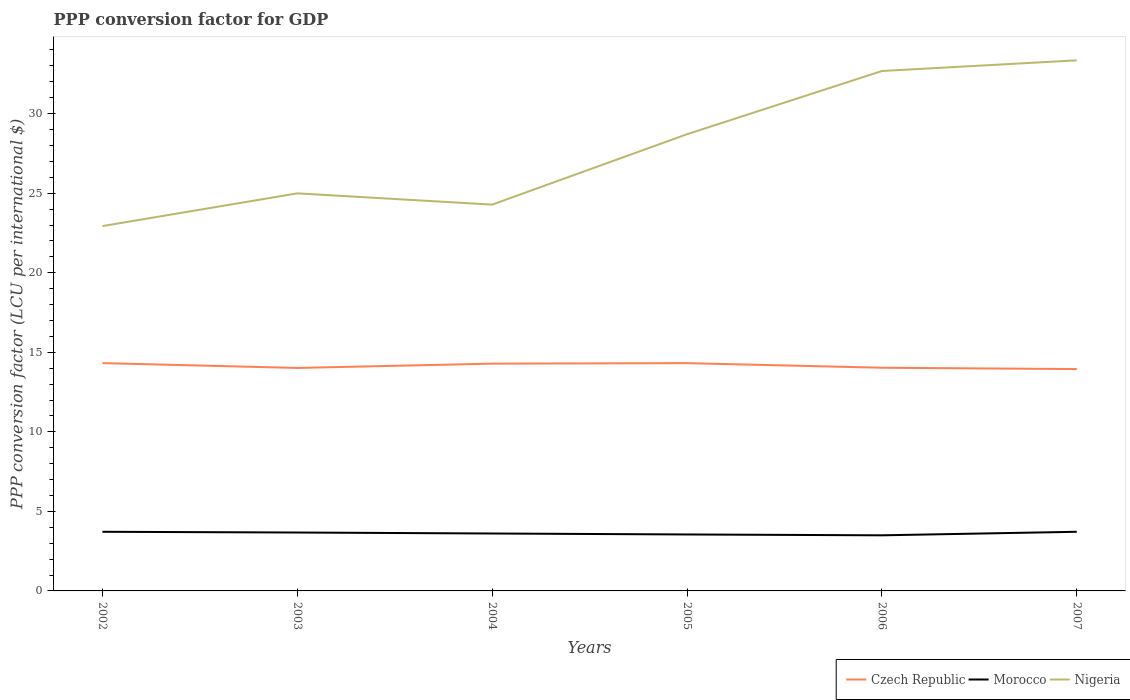How many different coloured lines are there?
Keep it short and to the point. 3. Does the line corresponding to Nigeria intersect with the line corresponding to Czech Republic?
Ensure brevity in your answer.  No. Is the number of lines equal to the number of legend labels?
Ensure brevity in your answer.  Yes. Across all years, what is the maximum PPP conversion factor for GDP in Morocco?
Your response must be concise. 3.49. What is the total PPP conversion factor for GDP in Nigeria in the graph?
Provide a succinct answer. -10.42. What is the difference between the highest and the second highest PPP conversion factor for GDP in Morocco?
Offer a terse response. 0.22. What is the difference between the highest and the lowest PPP conversion factor for GDP in Czech Republic?
Offer a terse response. 3. Is the PPP conversion factor for GDP in Czech Republic strictly greater than the PPP conversion factor for GDP in Nigeria over the years?
Your answer should be very brief. Yes. How many lines are there?
Keep it short and to the point. 3. How many years are there in the graph?
Offer a very short reply. 6. Are the values on the major ticks of Y-axis written in scientific E-notation?
Offer a terse response. No. Does the graph contain grids?
Offer a terse response. No. Where does the legend appear in the graph?
Offer a terse response. Bottom right. How are the legend labels stacked?
Give a very brief answer. Horizontal. What is the title of the graph?
Make the answer very short. PPP conversion factor for GDP. Does "Luxembourg" appear as one of the legend labels in the graph?
Ensure brevity in your answer.  No. What is the label or title of the Y-axis?
Offer a terse response. PPP conversion factor (LCU per international $). What is the PPP conversion factor (LCU per international $) of Czech Republic in 2002?
Offer a very short reply. 14.32. What is the PPP conversion factor (LCU per international $) of Morocco in 2002?
Keep it short and to the point. 3.72. What is the PPP conversion factor (LCU per international $) of Nigeria in 2002?
Offer a terse response. 22.93. What is the PPP conversion factor (LCU per international $) in Czech Republic in 2003?
Provide a short and direct response. 14.01. What is the PPP conversion factor (LCU per international $) of Morocco in 2003?
Provide a succinct answer. 3.67. What is the PPP conversion factor (LCU per international $) of Nigeria in 2003?
Ensure brevity in your answer.  24.99. What is the PPP conversion factor (LCU per international $) in Czech Republic in 2004?
Provide a short and direct response. 14.29. What is the PPP conversion factor (LCU per international $) in Morocco in 2004?
Provide a succinct answer. 3.61. What is the PPP conversion factor (LCU per international $) in Nigeria in 2004?
Keep it short and to the point. 24.28. What is the PPP conversion factor (LCU per international $) in Czech Republic in 2005?
Ensure brevity in your answer.  14.32. What is the PPP conversion factor (LCU per international $) in Morocco in 2005?
Your response must be concise. 3.55. What is the PPP conversion factor (LCU per international $) in Nigeria in 2005?
Provide a succinct answer. 28.71. What is the PPP conversion factor (LCU per international $) in Czech Republic in 2006?
Offer a terse response. 14.03. What is the PPP conversion factor (LCU per international $) of Morocco in 2006?
Give a very brief answer. 3.49. What is the PPP conversion factor (LCU per international $) of Nigeria in 2006?
Make the answer very short. 32.68. What is the PPP conversion factor (LCU per international $) in Czech Republic in 2007?
Your answer should be very brief. 13.94. What is the PPP conversion factor (LCU per international $) of Morocco in 2007?
Your response must be concise. 3.72. What is the PPP conversion factor (LCU per international $) in Nigeria in 2007?
Your answer should be compact. 33.35. Across all years, what is the maximum PPP conversion factor (LCU per international $) of Czech Republic?
Offer a terse response. 14.32. Across all years, what is the maximum PPP conversion factor (LCU per international $) in Morocco?
Provide a succinct answer. 3.72. Across all years, what is the maximum PPP conversion factor (LCU per international $) of Nigeria?
Your answer should be very brief. 33.35. Across all years, what is the minimum PPP conversion factor (LCU per international $) of Czech Republic?
Keep it short and to the point. 13.94. Across all years, what is the minimum PPP conversion factor (LCU per international $) of Morocco?
Ensure brevity in your answer.  3.49. Across all years, what is the minimum PPP conversion factor (LCU per international $) in Nigeria?
Offer a very short reply. 22.93. What is the total PPP conversion factor (LCU per international $) in Czech Republic in the graph?
Give a very brief answer. 84.91. What is the total PPP conversion factor (LCU per international $) of Morocco in the graph?
Your answer should be very brief. 21.76. What is the total PPP conversion factor (LCU per international $) in Nigeria in the graph?
Your answer should be very brief. 166.94. What is the difference between the PPP conversion factor (LCU per international $) in Czech Republic in 2002 and that in 2003?
Keep it short and to the point. 0.3. What is the difference between the PPP conversion factor (LCU per international $) in Morocco in 2002 and that in 2003?
Your answer should be compact. 0.05. What is the difference between the PPP conversion factor (LCU per international $) in Nigeria in 2002 and that in 2003?
Offer a terse response. -2.06. What is the difference between the PPP conversion factor (LCU per international $) in Czech Republic in 2002 and that in 2004?
Offer a terse response. 0.03. What is the difference between the PPP conversion factor (LCU per international $) in Morocco in 2002 and that in 2004?
Keep it short and to the point. 0.11. What is the difference between the PPP conversion factor (LCU per international $) in Nigeria in 2002 and that in 2004?
Make the answer very short. -1.35. What is the difference between the PPP conversion factor (LCU per international $) in Czech Republic in 2002 and that in 2005?
Offer a very short reply. 0. What is the difference between the PPP conversion factor (LCU per international $) in Morocco in 2002 and that in 2005?
Ensure brevity in your answer.  0.17. What is the difference between the PPP conversion factor (LCU per international $) of Nigeria in 2002 and that in 2005?
Your answer should be compact. -5.77. What is the difference between the PPP conversion factor (LCU per international $) of Czech Republic in 2002 and that in 2006?
Your answer should be very brief. 0.29. What is the difference between the PPP conversion factor (LCU per international $) in Morocco in 2002 and that in 2006?
Your answer should be compact. 0.22. What is the difference between the PPP conversion factor (LCU per international $) of Nigeria in 2002 and that in 2006?
Offer a terse response. -9.75. What is the difference between the PPP conversion factor (LCU per international $) in Czech Republic in 2002 and that in 2007?
Provide a short and direct response. 0.38. What is the difference between the PPP conversion factor (LCU per international $) of Morocco in 2002 and that in 2007?
Your response must be concise. -0. What is the difference between the PPP conversion factor (LCU per international $) of Nigeria in 2002 and that in 2007?
Your answer should be very brief. -10.42. What is the difference between the PPP conversion factor (LCU per international $) in Czech Republic in 2003 and that in 2004?
Give a very brief answer. -0.27. What is the difference between the PPP conversion factor (LCU per international $) of Morocco in 2003 and that in 2004?
Offer a very short reply. 0.06. What is the difference between the PPP conversion factor (LCU per international $) of Nigeria in 2003 and that in 2004?
Your response must be concise. 0.71. What is the difference between the PPP conversion factor (LCU per international $) of Czech Republic in 2003 and that in 2005?
Offer a terse response. -0.3. What is the difference between the PPP conversion factor (LCU per international $) of Morocco in 2003 and that in 2005?
Make the answer very short. 0.12. What is the difference between the PPP conversion factor (LCU per international $) of Nigeria in 2003 and that in 2005?
Provide a succinct answer. -3.72. What is the difference between the PPP conversion factor (LCU per international $) in Czech Republic in 2003 and that in 2006?
Provide a short and direct response. -0.01. What is the difference between the PPP conversion factor (LCU per international $) of Morocco in 2003 and that in 2006?
Make the answer very short. 0.18. What is the difference between the PPP conversion factor (LCU per international $) of Nigeria in 2003 and that in 2006?
Provide a succinct answer. -7.69. What is the difference between the PPP conversion factor (LCU per international $) in Czech Republic in 2003 and that in 2007?
Your response must be concise. 0.07. What is the difference between the PPP conversion factor (LCU per international $) of Morocco in 2003 and that in 2007?
Your response must be concise. -0.05. What is the difference between the PPP conversion factor (LCU per international $) of Nigeria in 2003 and that in 2007?
Give a very brief answer. -8.36. What is the difference between the PPP conversion factor (LCU per international $) of Czech Republic in 2004 and that in 2005?
Offer a terse response. -0.03. What is the difference between the PPP conversion factor (LCU per international $) of Morocco in 2004 and that in 2005?
Give a very brief answer. 0.06. What is the difference between the PPP conversion factor (LCU per international $) in Nigeria in 2004 and that in 2005?
Ensure brevity in your answer.  -4.42. What is the difference between the PPP conversion factor (LCU per international $) of Czech Republic in 2004 and that in 2006?
Provide a short and direct response. 0.26. What is the difference between the PPP conversion factor (LCU per international $) in Morocco in 2004 and that in 2006?
Your response must be concise. 0.11. What is the difference between the PPP conversion factor (LCU per international $) in Nigeria in 2004 and that in 2006?
Your answer should be very brief. -8.4. What is the difference between the PPP conversion factor (LCU per international $) of Czech Republic in 2004 and that in 2007?
Your answer should be very brief. 0.34. What is the difference between the PPP conversion factor (LCU per international $) of Morocco in 2004 and that in 2007?
Your answer should be very brief. -0.11. What is the difference between the PPP conversion factor (LCU per international $) in Nigeria in 2004 and that in 2007?
Provide a short and direct response. -9.07. What is the difference between the PPP conversion factor (LCU per international $) in Czech Republic in 2005 and that in 2006?
Ensure brevity in your answer.  0.29. What is the difference between the PPP conversion factor (LCU per international $) in Morocco in 2005 and that in 2006?
Your answer should be very brief. 0.05. What is the difference between the PPP conversion factor (LCU per international $) of Nigeria in 2005 and that in 2006?
Offer a terse response. -3.97. What is the difference between the PPP conversion factor (LCU per international $) of Czech Republic in 2005 and that in 2007?
Offer a very short reply. 0.37. What is the difference between the PPP conversion factor (LCU per international $) of Morocco in 2005 and that in 2007?
Make the answer very short. -0.17. What is the difference between the PPP conversion factor (LCU per international $) of Nigeria in 2005 and that in 2007?
Provide a succinct answer. -4.64. What is the difference between the PPP conversion factor (LCU per international $) of Czech Republic in 2006 and that in 2007?
Your response must be concise. 0.09. What is the difference between the PPP conversion factor (LCU per international $) in Morocco in 2006 and that in 2007?
Provide a succinct answer. -0.22. What is the difference between the PPP conversion factor (LCU per international $) in Nigeria in 2006 and that in 2007?
Provide a succinct answer. -0.67. What is the difference between the PPP conversion factor (LCU per international $) in Czech Republic in 2002 and the PPP conversion factor (LCU per international $) in Morocco in 2003?
Your answer should be compact. 10.65. What is the difference between the PPP conversion factor (LCU per international $) of Czech Republic in 2002 and the PPP conversion factor (LCU per international $) of Nigeria in 2003?
Provide a short and direct response. -10.67. What is the difference between the PPP conversion factor (LCU per international $) in Morocco in 2002 and the PPP conversion factor (LCU per international $) in Nigeria in 2003?
Provide a succinct answer. -21.27. What is the difference between the PPP conversion factor (LCU per international $) of Czech Republic in 2002 and the PPP conversion factor (LCU per international $) of Morocco in 2004?
Offer a very short reply. 10.71. What is the difference between the PPP conversion factor (LCU per international $) in Czech Republic in 2002 and the PPP conversion factor (LCU per international $) in Nigeria in 2004?
Make the answer very short. -9.96. What is the difference between the PPP conversion factor (LCU per international $) in Morocco in 2002 and the PPP conversion factor (LCU per international $) in Nigeria in 2004?
Give a very brief answer. -20.57. What is the difference between the PPP conversion factor (LCU per international $) of Czech Republic in 2002 and the PPP conversion factor (LCU per international $) of Morocco in 2005?
Your answer should be very brief. 10.77. What is the difference between the PPP conversion factor (LCU per international $) in Czech Republic in 2002 and the PPP conversion factor (LCU per international $) in Nigeria in 2005?
Provide a short and direct response. -14.39. What is the difference between the PPP conversion factor (LCU per international $) of Morocco in 2002 and the PPP conversion factor (LCU per international $) of Nigeria in 2005?
Provide a short and direct response. -24.99. What is the difference between the PPP conversion factor (LCU per international $) of Czech Republic in 2002 and the PPP conversion factor (LCU per international $) of Morocco in 2006?
Provide a short and direct response. 10.82. What is the difference between the PPP conversion factor (LCU per international $) of Czech Republic in 2002 and the PPP conversion factor (LCU per international $) of Nigeria in 2006?
Your answer should be very brief. -18.36. What is the difference between the PPP conversion factor (LCU per international $) in Morocco in 2002 and the PPP conversion factor (LCU per international $) in Nigeria in 2006?
Offer a terse response. -28.96. What is the difference between the PPP conversion factor (LCU per international $) of Czech Republic in 2002 and the PPP conversion factor (LCU per international $) of Morocco in 2007?
Your response must be concise. 10.6. What is the difference between the PPP conversion factor (LCU per international $) in Czech Republic in 2002 and the PPP conversion factor (LCU per international $) in Nigeria in 2007?
Ensure brevity in your answer.  -19.03. What is the difference between the PPP conversion factor (LCU per international $) of Morocco in 2002 and the PPP conversion factor (LCU per international $) of Nigeria in 2007?
Provide a short and direct response. -29.63. What is the difference between the PPP conversion factor (LCU per international $) in Czech Republic in 2003 and the PPP conversion factor (LCU per international $) in Morocco in 2004?
Keep it short and to the point. 10.41. What is the difference between the PPP conversion factor (LCU per international $) in Czech Republic in 2003 and the PPP conversion factor (LCU per international $) in Nigeria in 2004?
Your response must be concise. -10.27. What is the difference between the PPP conversion factor (LCU per international $) in Morocco in 2003 and the PPP conversion factor (LCU per international $) in Nigeria in 2004?
Provide a short and direct response. -20.61. What is the difference between the PPP conversion factor (LCU per international $) in Czech Republic in 2003 and the PPP conversion factor (LCU per international $) in Morocco in 2005?
Provide a succinct answer. 10.47. What is the difference between the PPP conversion factor (LCU per international $) of Czech Republic in 2003 and the PPP conversion factor (LCU per international $) of Nigeria in 2005?
Make the answer very short. -14.69. What is the difference between the PPP conversion factor (LCU per international $) of Morocco in 2003 and the PPP conversion factor (LCU per international $) of Nigeria in 2005?
Provide a succinct answer. -25.04. What is the difference between the PPP conversion factor (LCU per international $) of Czech Republic in 2003 and the PPP conversion factor (LCU per international $) of Morocco in 2006?
Provide a short and direct response. 10.52. What is the difference between the PPP conversion factor (LCU per international $) of Czech Republic in 2003 and the PPP conversion factor (LCU per international $) of Nigeria in 2006?
Ensure brevity in your answer.  -18.67. What is the difference between the PPP conversion factor (LCU per international $) of Morocco in 2003 and the PPP conversion factor (LCU per international $) of Nigeria in 2006?
Offer a very short reply. -29.01. What is the difference between the PPP conversion factor (LCU per international $) in Czech Republic in 2003 and the PPP conversion factor (LCU per international $) in Morocco in 2007?
Ensure brevity in your answer.  10.3. What is the difference between the PPP conversion factor (LCU per international $) of Czech Republic in 2003 and the PPP conversion factor (LCU per international $) of Nigeria in 2007?
Make the answer very short. -19.34. What is the difference between the PPP conversion factor (LCU per international $) of Morocco in 2003 and the PPP conversion factor (LCU per international $) of Nigeria in 2007?
Provide a succinct answer. -29.68. What is the difference between the PPP conversion factor (LCU per international $) of Czech Republic in 2004 and the PPP conversion factor (LCU per international $) of Morocco in 2005?
Keep it short and to the point. 10.74. What is the difference between the PPP conversion factor (LCU per international $) in Czech Republic in 2004 and the PPP conversion factor (LCU per international $) in Nigeria in 2005?
Your response must be concise. -14.42. What is the difference between the PPP conversion factor (LCU per international $) in Morocco in 2004 and the PPP conversion factor (LCU per international $) in Nigeria in 2005?
Provide a short and direct response. -25.1. What is the difference between the PPP conversion factor (LCU per international $) of Czech Republic in 2004 and the PPP conversion factor (LCU per international $) of Morocco in 2006?
Offer a very short reply. 10.79. What is the difference between the PPP conversion factor (LCU per international $) in Czech Republic in 2004 and the PPP conversion factor (LCU per international $) in Nigeria in 2006?
Give a very brief answer. -18.39. What is the difference between the PPP conversion factor (LCU per international $) in Morocco in 2004 and the PPP conversion factor (LCU per international $) in Nigeria in 2006?
Your response must be concise. -29.07. What is the difference between the PPP conversion factor (LCU per international $) of Czech Republic in 2004 and the PPP conversion factor (LCU per international $) of Morocco in 2007?
Your answer should be very brief. 10.57. What is the difference between the PPP conversion factor (LCU per international $) of Czech Republic in 2004 and the PPP conversion factor (LCU per international $) of Nigeria in 2007?
Make the answer very short. -19.07. What is the difference between the PPP conversion factor (LCU per international $) of Morocco in 2004 and the PPP conversion factor (LCU per international $) of Nigeria in 2007?
Offer a very short reply. -29.74. What is the difference between the PPP conversion factor (LCU per international $) in Czech Republic in 2005 and the PPP conversion factor (LCU per international $) in Morocco in 2006?
Keep it short and to the point. 10.82. What is the difference between the PPP conversion factor (LCU per international $) in Czech Republic in 2005 and the PPP conversion factor (LCU per international $) in Nigeria in 2006?
Offer a terse response. -18.36. What is the difference between the PPP conversion factor (LCU per international $) in Morocco in 2005 and the PPP conversion factor (LCU per international $) in Nigeria in 2006?
Your answer should be compact. -29.13. What is the difference between the PPP conversion factor (LCU per international $) of Czech Republic in 2005 and the PPP conversion factor (LCU per international $) of Morocco in 2007?
Your answer should be very brief. 10.6. What is the difference between the PPP conversion factor (LCU per international $) of Czech Republic in 2005 and the PPP conversion factor (LCU per international $) of Nigeria in 2007?
Your answer should be very brief. -19.03. What is the difference between the PPP conversion factor (LCU per international $) in Morocco in 2005 and the PPP conversion factor (LCU per international $) in Nigeria in 2007?
Give a very brief answer. -29.8. What is the difference between the PPP conversion factor (LCU per international $) of Czech Republic in 2006 and the PPP conversion factor (LCU per international $) of Morocco in 2007?
Your answer should be very brief. 10.31. What is the difference between the PPP conversion factor (LCU per international $) in Czech Republic in 2006 and the PPP conversion factor (LCU per international $) in Nigeria in 2007?
Give a very brief answer. -19.32. What is the difference between the PPP conversion factor (LCU per international $) of Morocco in 2006 and the PPP conversion factor (LCU per international $) of Nigeria in 2007?
Keep it short and to the point. -29.86. What is the average PPP conversion factor (LCU per international $) in Czech Republic per year?
Offer a terse response. 14.15. What is the average PPP conversion factor (LCU per international $) in Morocco per year?
Keep it short and to the point. 3.63. What is the average PPP conversion factor (LCU per international $) in Nigeria per year?
Offer a terse response. 27.82. In the year 2002, what is the difference between the PPP conversion factor (LCU per international $) of Czech Republic and PPP conversion factor (LCU per international $) of Morocco?
Provide a succinct answer. 10.6. In the year 2002, what is the difference between the PPP conversion factor (LCU per international $) in Czech Republic and PPP conversion factor (LCU per international $) in Nigeria?
Provide a succinct answer. -8.61. In the year 2002, what is the difference between the PPP conversion factor (LCU per international $) in Morocco and PPP conversion factor (LCU per international $) in Nigeria?
Provide a short and direct response. -19.22. In the year 2003, what is the difference between the PPP conversion factor (LCU per international $) of Czech Republic and PPP conversion factor (LCU per international $) of Morocco?
Give a very brief answer. 10.34. In the year 2003, what is the difference between the PPP conversion factor (LCU per international $) of Czech Republic and PPP conversion factor (LCU per international $) of Nigeria?
Make the answer very short. -10.97. In the year 2003, what is the difference between the PPP conversion factor (LCU per international $) in Morocco and PPP conversion factor (LCU per international $) in Nigeria?
Offer a terse response. -21.32. In the year 2004, what is the difference between the PPP conversion factor (LCU per international $) of Czech Republic and PPP conversion factor (LCU per international $) of Morocco?
Offer a very short reply. 10.68. In the year 2004, what is the difference between the PPP conversion factor (LCU per international $) in Czech Republic and PPP conversion factor (LCU per international $) in Nigeria?
Provide a short and direct response. -10. In the year 2004, what is the difference between the PPP conversion factor (LCU per international $) of Morocco and PPP conversion factor (LCU per international $) of Nigeria?
Your answer should be compact. -20.67. In the year 2005, what is the difference between the PPP conversion factor (LCU per international $) in Czech Republic and PPP conversion factor (LCU per international $) in Morocco?
Make the answer very short. 10.77. In the year 2005, what is the difference between the PPP conversion factor (LCU per international $) in Czech Republic and PPP conversion factor (LCU per international $) in Nigeria?
Provide a short and direct response. -14.39. In the year 2005, what is the difference between the PPP conversion factor (LCU per international $) in Morocco and PPP conversion factor (LCU per international $) in Nigeria?
Ensure brevity in your answer.  -25.16. In the year 2006, what is the difference between the PPP conversion factor (LCU per international $) of Czech Republic and PPP conversion factor (LCU per international $) of Morocco?
Offer a terse response. 10.53. In the year 2006, what is the difference between the PPP conversion factor (LCU per international $) in Czech Republic and PPP conversion factor (LCU per international $) in Nigeria?
Give a very brief answer. -18.65. In the year 2006, what is the difference between the PPP conversion factor (LCU per international $) in Morocco and PPP conversion factor (LCU per international $) in Nigeria?
Ensure brevity in your answer.  -29.18. In the year 2007, what is the difference between the PPP conversion factor (LCU per international $) of Czech Republic and PPP conversion factor (LCU per international $) of Morocco?
Your response must be concise. 10.23. In the year 2007, what is the difference between the PPP conversion factor (LCU per international $) of Czech Republic and PPP conversion factor (LCU per international $) of Nigeria?
Make the answer very short. -19.41. In the year 2007, what is the difference between the PPP conversion factor (LCU per international $) in Morocco and PPP conversion factor (LCU per international $) in Nigeria?
Offer a very short reply. -29.63. What is the ratio of the PPP conversion factor (LCU per international $) of Czech Republic in 2002 to that in 2003?
Your response must be concise. 1.02. What is the ratio of the PPP conversion factor (LCU per international $) of Morocco in 2002 to that in 2003?
Your answer should be compact. 1.01. What is the ratio of the PPP conversion factor (LCU per international $) in Nigeria in 2002 to that in 2003?
Ensure brevity in your answer.  0.92. What is the ratio of the PPP conversion factor (LCU per international $) in Morocco in 2002 to that in 2004?
Your answer should be compact. 1.03. What is the ratio of the PPP conversion factor (LCU per international $) in Czech Republic in 2002 to that in 2005?
Keep it short and to the point. 1. What is the ratio of the PPP conversion factor (LCU per international $) in Morocco in 2002 to that in 2005?
Keep it short and to the point. 1.05. What is the ratio of the PPP conversion factor (LCU per international $) of Nigeria in 2002 to that in 2005?
Offer a terse response. 0.8. What is the ratio of the PPP conversion factor (LCU per international $) in Czech Republic in 2002 to that in 2006?
Give a very brief answer. 1.02. What is the ratio of the PPP conversion factor (LCU per international $) of Morocco in 2002 to that in 2006?
Provide a succinct answer. 1.06. What is the ratio of the PPP conversion factor (LCU per international $) in Nigeria in 2002 to that in 2006?
Ensure brevity in your answer.  0.7. What is the ratio of the PPP conversion factor (LCU per international $) in Czech Republic in 2002 to that in 2007?
Your answer should be compact. 1.03. What is the ratio of the PPP conversion factor (LCU per international $) of Nigeria in 2002 to that in 2007?
Your answer should be compact. 0.69. What is the ratio of the PPP conversion factor (LCU per international $) in Morocco in 2003 to that in 2004?
Your response must be concise. 1.02. What is the ratio of the PPP conversion factor (LCU per international $) in Nigeria in 2003 to that in 2004?
Offer a terse response. 1.03. What is the ratio of the PPP conversion factor (LCU per international $) of Czech Republic in 2003 to that in 2005?
Your response must be concise. 0.98. What is the ratio of the PPP conversion factor (LCU per international $) in Morocco in 2003 to that in 2005?
Make the answer very short. 1.03. What is the ratio of the PPP conversion factor (LCU per international $) in Nigeria in 2003 to that in 2005?
Provide a short and direct response. 0.87. What is the ratio of the PPP conversion factor (LCU per international $) in Morocco in 2003 to that in 2006?
Give a very brief answer. 1.05. What is the ratio of the PPP conversion factor (LCU per international $) in Nigeria in 2003 to that in 2006?
Your answer should be compact. 0.76. What is the ratio of the PPP conversion factor (LCU per international $) of Czech Republic in 2003 to that in 2007?
Provide a succinct answer. 1.01. What is the ratio of the PPP conversion factor (LCU per international $) in Morocco in 2003 to that in 2007?
Provide a succinct answer. 0.99. What is the ratio of the PPP conversion factor (LCU per international $) in Nigeria in 2003 to that in 2007?
Ensure brevity in your answer.  0.75. What is the ratio of the PPP conversion factor (LCU per international $) of Morocco in 2004 to that in 2005?
Offer a very short reply. 1.02. What is the ratio of the PPP conversion factor (LCU per international $) of Nigeria in 2004 to that in 2005?
Ensure brevity in your answer.  0.85. What is the ratio of the PPP conversion factor (LCU per international $) of Czech Republic in 2004 to that in 2006?
Give a very brief answer. 1.02. What is the ratio of the PPP conversion factor (LCU per international $) in Morocco in 2004 to that in 2006?
Provide a short and direct response. 1.03. What is the ratio of the PPP conversion factor (LCU per international $) of Nigeria in 2004 to that in 2006?
Give a very brief answer. 0.74. What is the ratio of the PPP conversion factor (LCU per international $) in Czech Republic in 2004 to that in 2007?
Provide a short and direct response. 1.02. What is the ratio of the PPP conversion factor (LCU per international $) of Morocco in 2004 to that in 2007?
Your answer should be very brief. 0.97. What is the ratio of the PPP conversion factor (LCU per international $) in Nigeria in 2004 to that in 2007?
Make the answer very short. 0.73. What is the ratio of the PPP conversion factor (LCU per international $) in Czech Republic in 2005 to that in 2006?
Make the answer very short. 1.02. What is the ratio of the PPP conversion factor (LCU per international $) of Morocco in 2005 to that in 2006?
Provide a succinct answer. 1.02. What is the ratio of the PPP conversion factor (LCU per international $) of Nigeria in 2005 to that in 2006?
Make the answer very short. 0.88. What is the ratio of the PPP conversion factor (LCU per international $) of Czech Republic in 2005 to that in 2007?
Offer a terse response. 1.03. What is the ratio of the PPP conversion factor (LCU per international $) in Morocco in 2005 to that in 2007?
Your answer should be compact. 0.95. What is the ratio of the PPP conversion factor (LCU per international $) in Nigeria in 2005 to that in 2007?
Make the answer very short. 0.86. What is the ratio of the PPP conversion factor (LCU per international $) in Morocco in 2006 to that in 2007?
Your response must be concise. 0.94. What is the ratio of the PPP conversion factor (LCU per international $) of Nigeria in 2006 to that in 2007?
Make the answer very short. 0.98. What is the difference between the highest and the second highest PPP conversion factor (LCU per international $) of Czech Republic?
Keep it short and to the point. 0. What is the difference between the highest and the second highest PPP conversion factor (LCU per international $) in Morocco?
Keep it short and to the point. 0. What is the difference between the highest and the second highest PPP conversion factor (LCU per international $) of Nigeria?
Provide a short and direct response. 0.67. What is the difference between the highest and the lowest PPP conversion factor (LCU per international $) of Czech Republic?
Your response must be concise. 0.38. What is the difference between the highest and the lowest PPP conversion factor (LCU per international $) of Morocco?
Your answer should be compact. 0.22. What is the difference between the highest and the lowest PPP conversion factor (LCU per international $) in Nigeria?
Keep it short and to the point. 10.42. 